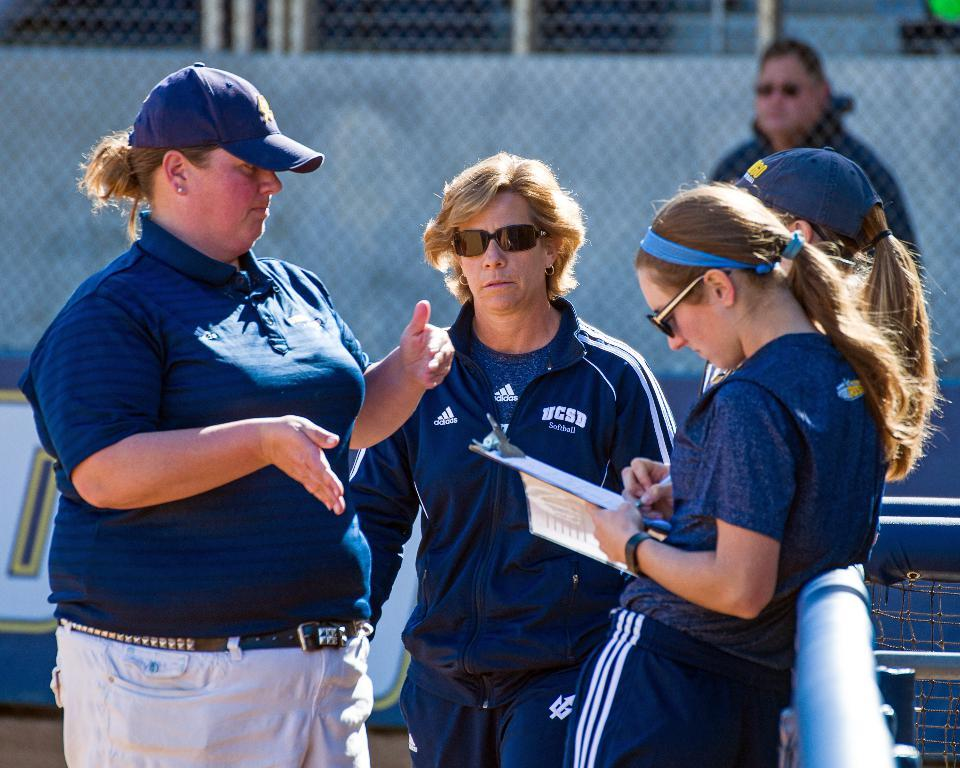<image>
Render a clear and concise summary of the photo. Women coaches for the UCSD Softball team are talking in a group. 